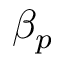Convert formula to latex. <formula><loc_0><loc_0><loc_500><loc_500>\beta _ { p }</formula> 